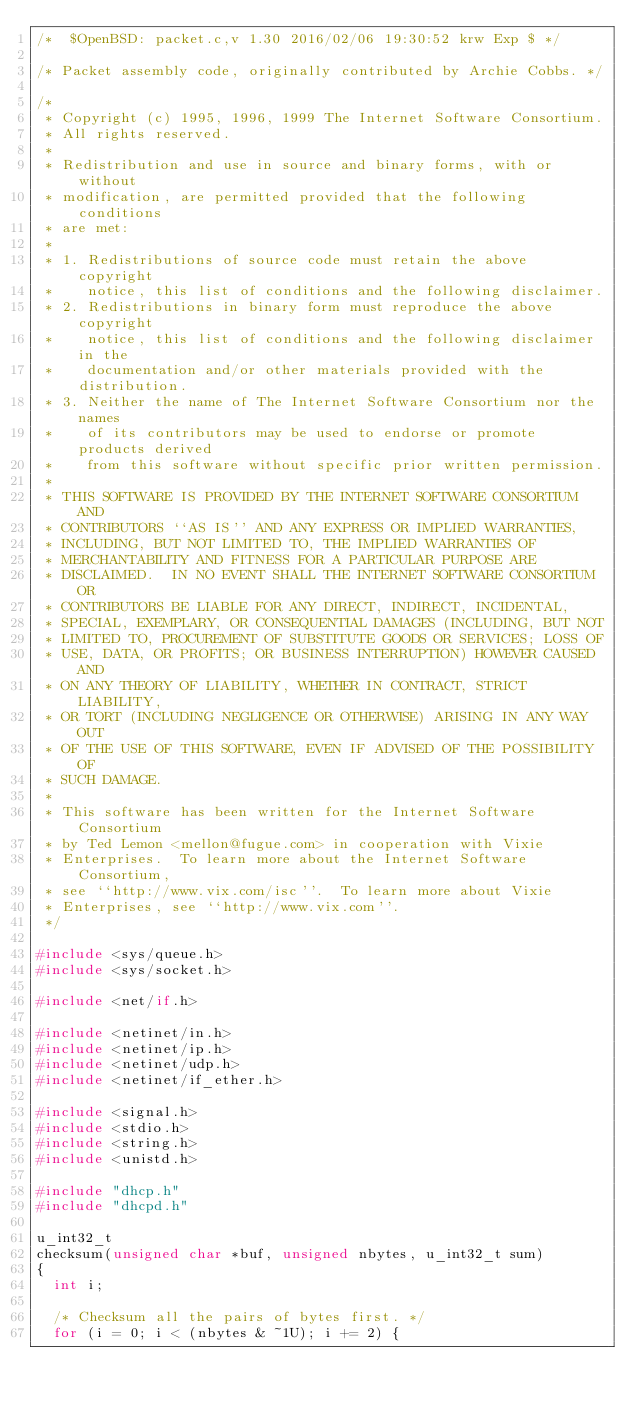<code> <loc_0><loc_0><loc_500><loc_500><_C_>/*	$OpenBSD: packet.c,v 1.30 2016/02/06 19:30:52 krw Exp $	*/

/* Packet assembly code, originally contributed by Archie Cobbs. */

/*
 * Copyright (c) 1995, 1996, 1999 The Internet Software Consortium.
 * All rights reserved.
 *
 * Redistribution and use in source and binary forms, with or without
 * modification, are permitted provided that the following conditions
 * are met:
 *
 * 1. Redistributions of source code must retain the above copyright
 *    notice, this list of conditions and the following disclaimer.
 * 2. Redistributions in binary form must reproduce the above copyright
 *    notice, this list of conditions and the following disclaimer in the
 *    documentation and/or other materials provided with the distribution.
 * 3. Neither the name of The Internet Software Consortium nor the names
 *    of its contributors may be used to endorse or promote products derived
 *    from this software without specific prior written permission.
 *
 * THIS SOFTWARE IS PROVIDED BY THE INTERNET SOFTWARE CONSORTIUM AND
 * CONTRIBUTORS ``AS IS'' AND ANY EXPRESS OR IMPLIED WARRANTIES,
 * INCLUDING, BUT NOT LIMITED TO, THE IMPLIED WARRANTIES OF
 * MERCHANTABILITY AND FITNESS FOR A PARTICULAR PURPOSE ARE
 * DISCLAIMED.  IN NO EVENT SHALL THE INTERNET SOFTWARE CONSORTIUM OR
 * CONTRIBUTORS BE LIABLE FOR ANY DIRECT, INDIRECT, INCIDENTAL,
 * SPECIAL, EXEMPLARY, OR CONSEQUENTIAL DAMAGES (INCLUDING, BUT NOT
 * LIMITED TO, PROCUREMENT OF SUBSTITUTE GOODS OR SERVICES; LOSS OF
 * USE, DATA, OR PROFITS; OR BUSINESS INTERRUPTION) HOWEVER CAUSED AND
 * ON ANY THEORY OF LIABILITY, WHETHER IN CONTRACT, STRICT LIABILITY,
 * OR TORT (INCLUDING NEGLIGENCE OR OTHERWISE) ARISING IN ANY WAY OUT
 * OF THE USE OF THIS SOFTWARE, EVEN IF ADVISED OF THE POSSIBILITY OF
 * SUCH DAMAGE.
 *
 * This software has been written for the Internet Software Consortium
 * by Ted Lemon <mellon@fugue.com> in cooperation with Vixie
 * Enterprises.  To learn more about the Internet Software Consortium,
 * see ``http://www.vix.com/isc''.  To learn more about Vixie
 * Enterprises, see ``http://www.vix.com''.
 */

#include <sys/queue.h>
#include <sys/socket.h>

#include <net/if.h>

#include <netinet/in.h>
#include <netinet/ip.h>
#include <netinet/udp.h>
#include <netinet/if_ether.h>

#include <signal.h>
#include <stdio.h>
#include <string.h>
#include <unistd.h>

#include "dhcp.h"
#include "dhcpd.h"

u_int32_t
checksum(unsigned char *buf, unsigned nbytes, u_int32_t sum)
{
	int i;

	/* Checksum all the pairs of bytes first. */
	for (i = 0; i < (nbytes & ~1U); i += 2) {</code> 